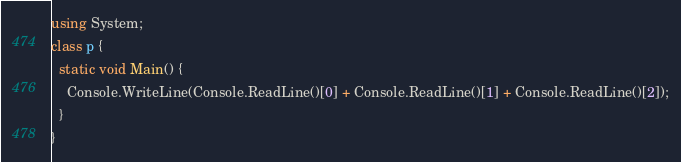<code> <loc_0><loc_0><loc_500><loc_500><_C#_>using System;
class p {
  static void Main() {
    Console.WriteLine(Console.ReadLine()[0] + Console.ReadLine()[1] + Console.ReadLine()[2]);
  }
}
</code> 